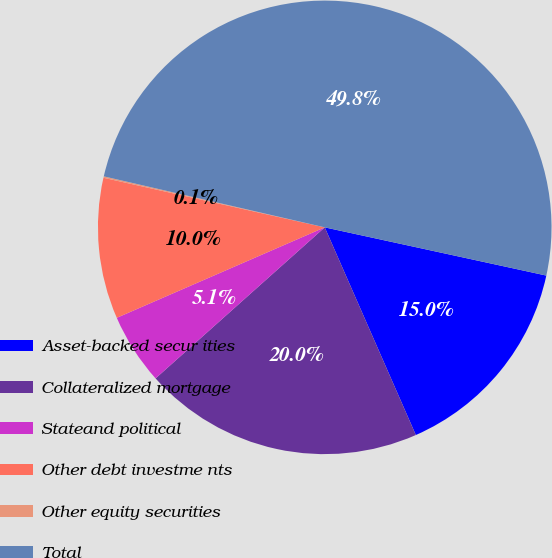Convert chart. <chart><loc_0><loc_0><loc_500><loc_500><pie_chart><fcel>Asset-backed secur ities<fcel>Collateralized mortgage<fcel>Stateand political<fcel>Other debt investme nts<fcel>Other equity securities<fcel>Total<nl><fcel>15.01%<fcel>19.98%<fcel>5.07%<fcel>10.04%<fcel>0.1%<fcel>49.8%<nl></chart> 